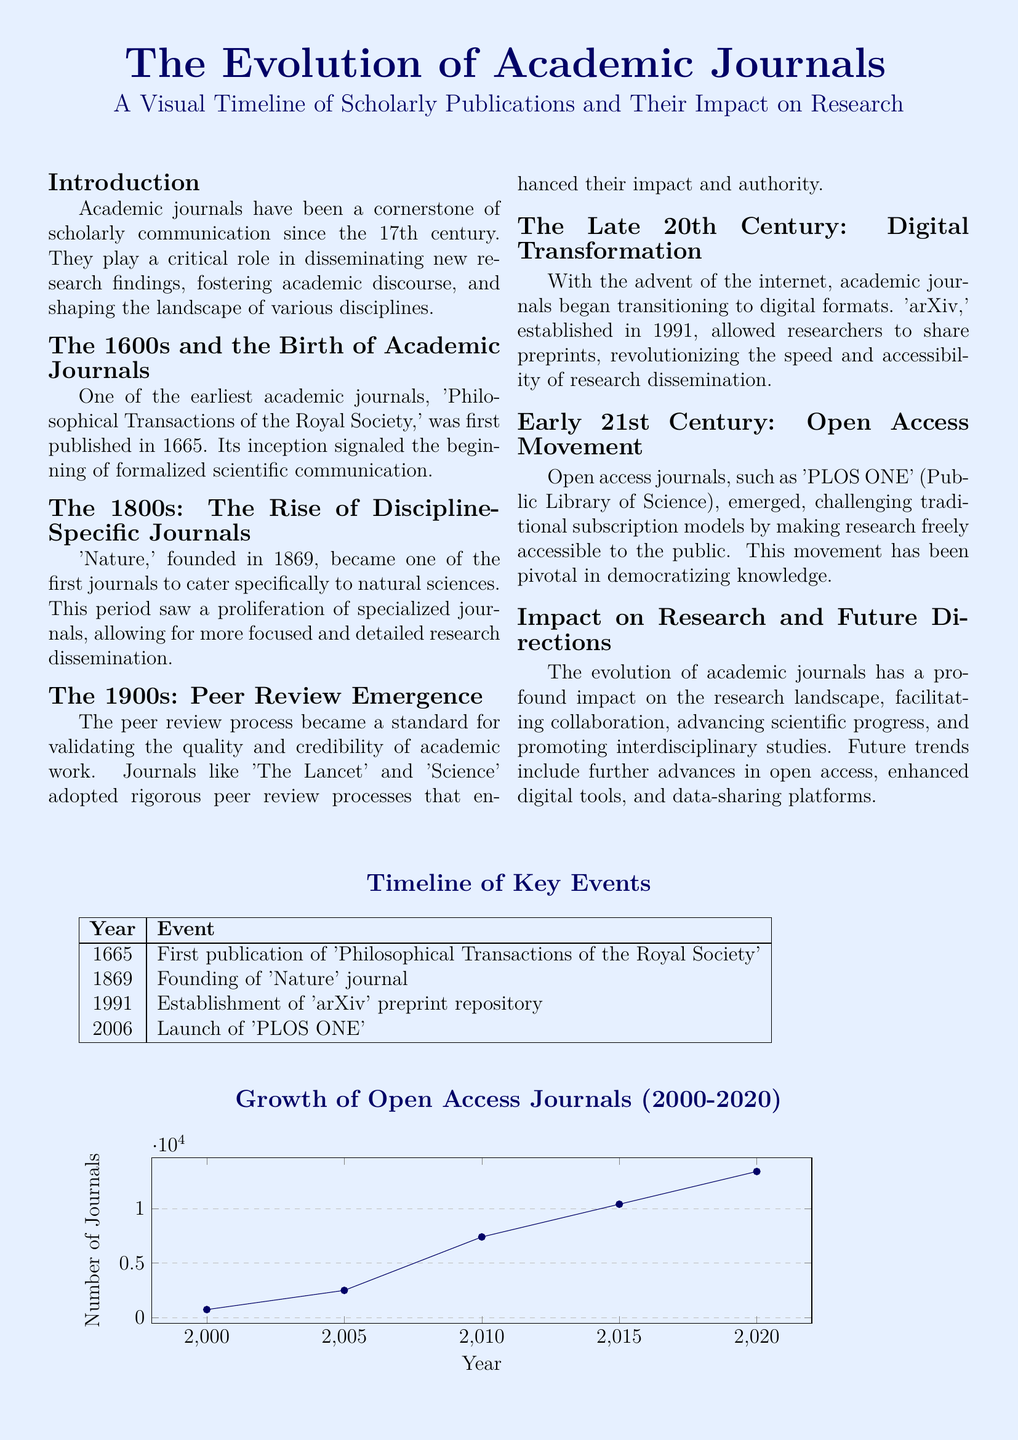What year was the 'Philosophical Transactions of the Royal Society' first published? The document states that it was first published in 1665.
Answer: 1665 What journal was founded in 1869? The document notes that 'Nature' was founded in 1869.
Answer: Nature What significant development in academic publishing occurred in 1991? According to the document, the establishment of 'arXiv' preprint repository took place in 1991.
Answer: arXiv How many journals were there in the year 2000 as shown in the growth chart? The document indicates that there were 740 open access journals in 2000.
Answer: 740 What was the primary purpose of the peer review process as described in the document? The peer review process is stated to validate the quality and credibility of academic work.
Answer: Validate quality Which journal is associated with the open access movement mentioned in the document? The document specifically highlights 'PLOS ONE' as a notable open access journal.
Answer: PLOS ONE What impact did digital transformation have on academic journals according to the document? The document states that digital transformation revolutionized the speed and accessibility of research dissemination.
Answer: Revolutionized speed What decade saw the rise of discipline-specific journals? The document mentions that the 1800s was the period when discipline-specific journals rose.
Answer: 1800s What does the timeline of key events include? The timeline includes significant events related to academic journals, such as founding years of notable journals.
Answer: Founding years What does the graph depict about the growth of open access journals from 2000 to 2020? The graph illustrates an increase in the number of open access journals over the specified period.
Answer: Increase in number 